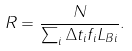Convert formula to latex. <formula><loc_0><loc_0><loc_500><loc_500>R = \frac { N } { \sum _ { i } \Delta t _ { i } f _ { i } L _ { B i } } .</formula> 